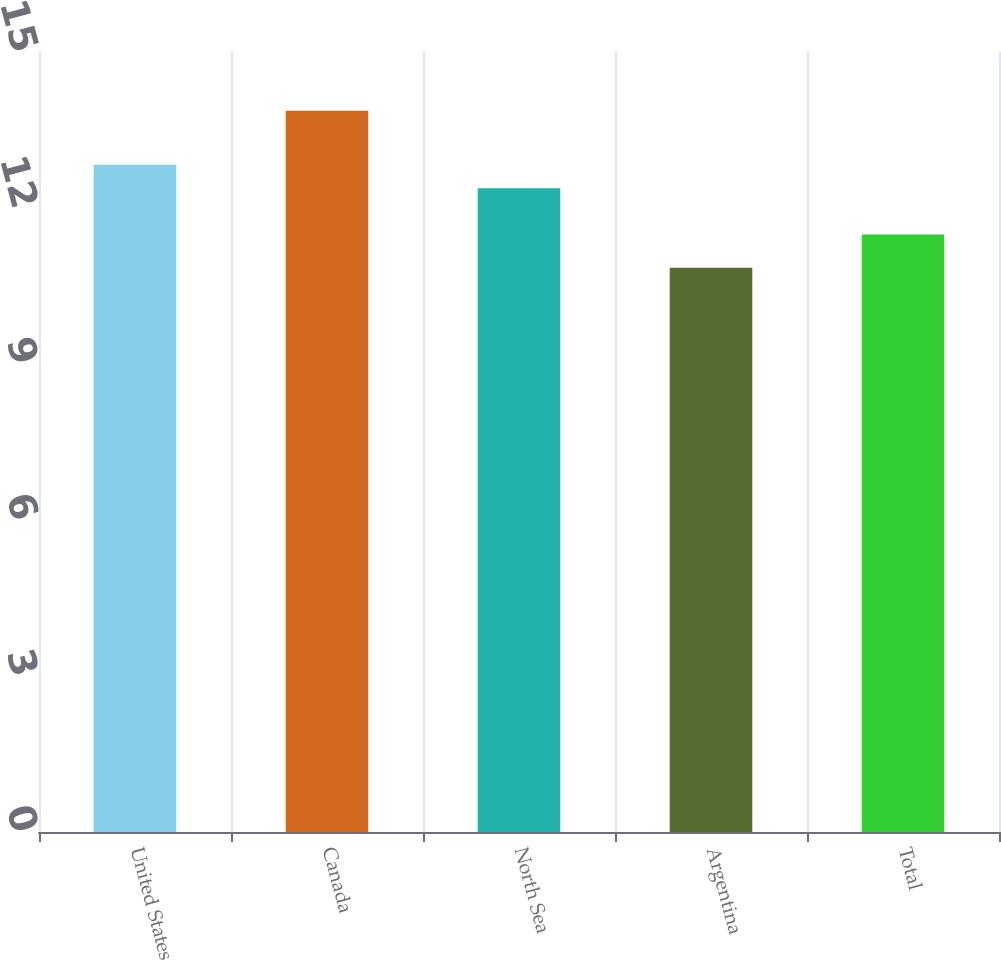Convert chart to OTSL. <chart><loc_0><loc_0><loc_500><loc_500><bar_chart><fcel>United States<fcel>Canada<fcel>North Sea<fcel>Argentina<fcel>Total<nl><fcel>12.83<fcel>13.87<fcel>12.38<fcel>10.85<fcel>11.49<nl></chart> 